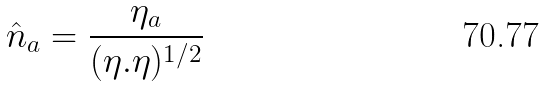<formula> <loc_0><loc_0><loc_500><loc_500>\hat { n } _ { a } = \frac { \eta _ { a } } { ( \eta . \eta ) ^ { 1 / 2 } }</formula> 